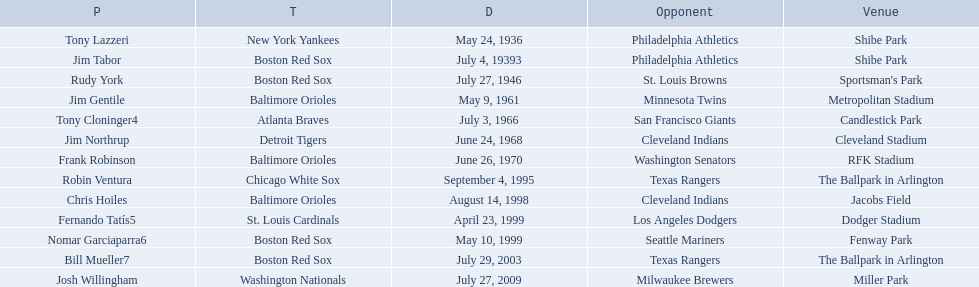Who are all the opponents? Philadelphia Athletics, Philadelphia Athletics, St. Louis Browns, Minnesota Twins, San Francisco Giants, Cleveland Indians, Washington Senators, Texas Rangers, Cleveland Indians, Los Angeles Dodgers, Seattle Mariners, Texas Rangers, Milwaukee Brewers. What teams played on july 27, 1946? Boston Red Sox, July 27, 1946, St. Louis Browns. Who was the opponent in this game? St. Louis Browns. 